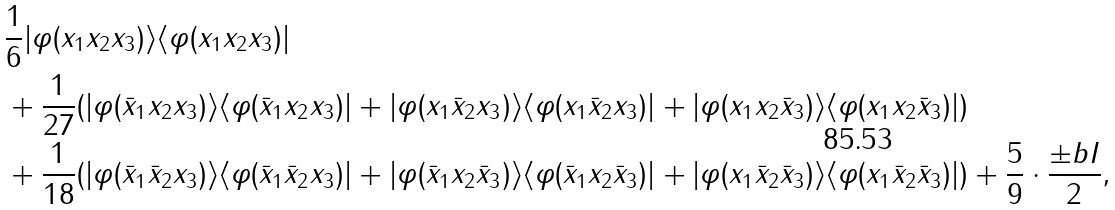Convert formula to latex. <formula><loc_0><loc_0><loc_500><loc_500>& \frac { 1 } { 6 } | \varphi ( x _ { 1 } x _ { 2 } x _ { 3 } ) \rangle \langle \varphi ( x _ { 1 } x _ { 2 } x _ { 3 } ) | \\ & + \frac { 1 } { 2 7 } ( | \varphi ( \bar { x } _ { 1 } x _ { 2 } x _ { 3 } ) \rangle \langle \varphi ( \bar { x } _ { 1 } x _ { 2 } x _ { 3 } ) | + | \varphi ( x _ { 1 } \bar { x } _ { 2 } x _ { 3 } ) \rangle \langle \varphi ( x _ { 1 } \bar { x } _ { 2 } x _ { 3 } ) | + | \varphi ( x _ { 1 } x _ { 2 } \bar { x } _ { 3 } ) \rangle \langle \varphi ( x _ { 1 } x _ { 2 } \bar { x } _ { 3 } ) | ) \\ & + \frac { 1 } { 1 8 } ( | \varphi ( \bar { x } _ { 1 } \bar { x } _ { 2 } x _ { 3 } ) \rangle \langle \varphi ( \bar { x } _ { 1 } \bar { x } _ { 2 } x _ { 3 } ) | + | \varphi ( \bar { x } _ { 1 } x _ { 2 } \bar { x } _ { 3 } ) \rangle \langle \varphi ( \bar { x } _ { 1 } x _ { 2 } \bar { x } _ { 3 } ) | + | \varphi ( x _ { 1 } \bar { x } _ { 2 } \bar { x } _ { 3 } ) \rangle \langle \varphi ( x _ { 1 } \bar { x } _ { 2 } \bar { x } _ { 3 } ) | ) + \frac { 5 } { 9 } \cdot \frac { \pm b { I } } { 2 } ,</formula> 